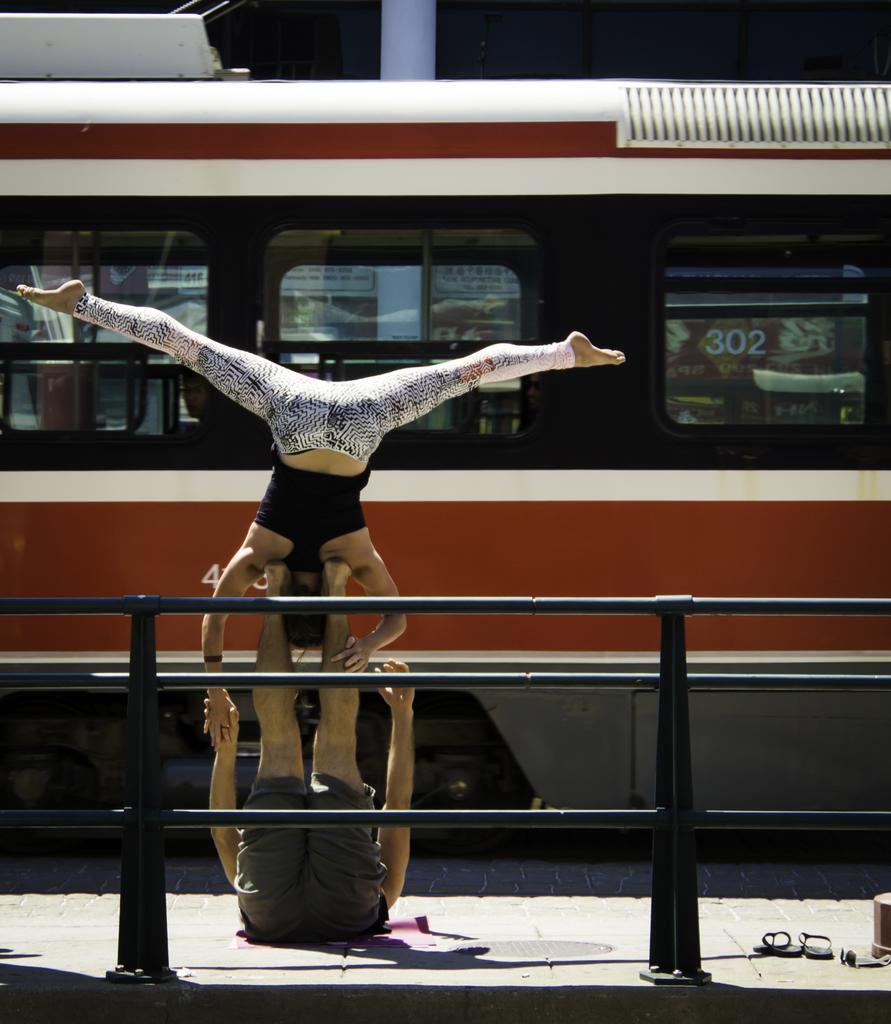In one or two sentences, can you explain what this image depicts? There are people, it seems like they are performing a stunt and a boundary in the foreground area of the image, it seems like a bus in the background. 